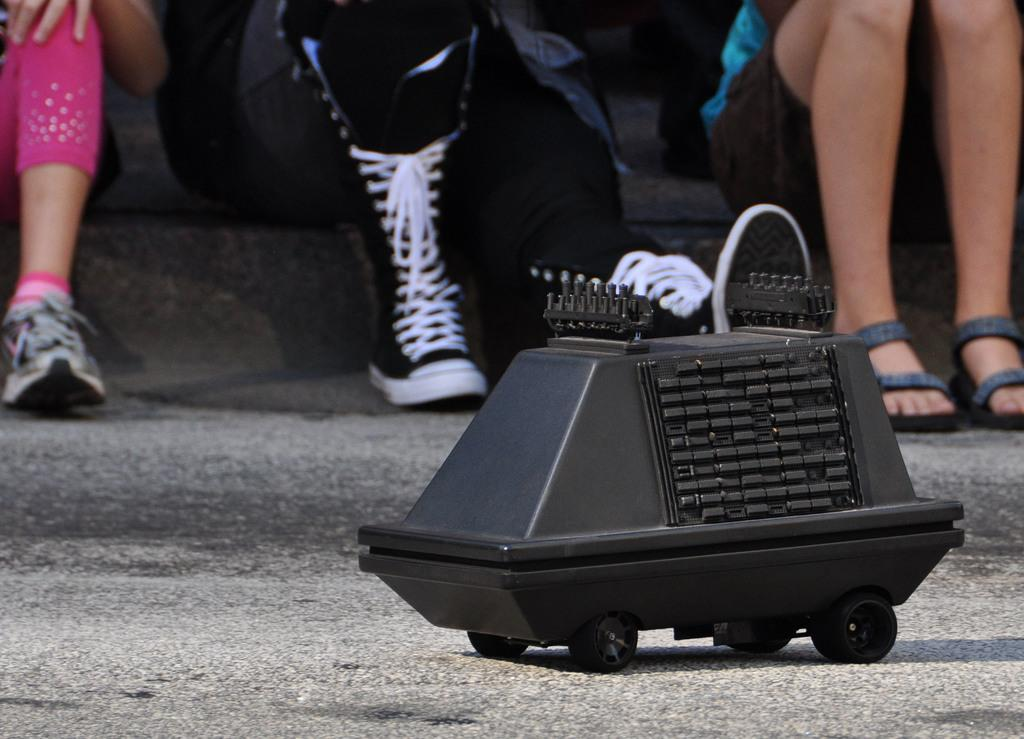What is the main object in the foreground of the image? There is a toy vehicle in the foreground of the image. What are the people in the image doing? There are three persons sitting on steps in the image. Can you tell if the image was taken during the day or night? The image was likely taken during the day, as there is no indication of darkness or artificial lighting. What type of voice can be heard coming from the toy vehicle in the image? There is no indication of sound or voice in the image, as it is a still photograph. 